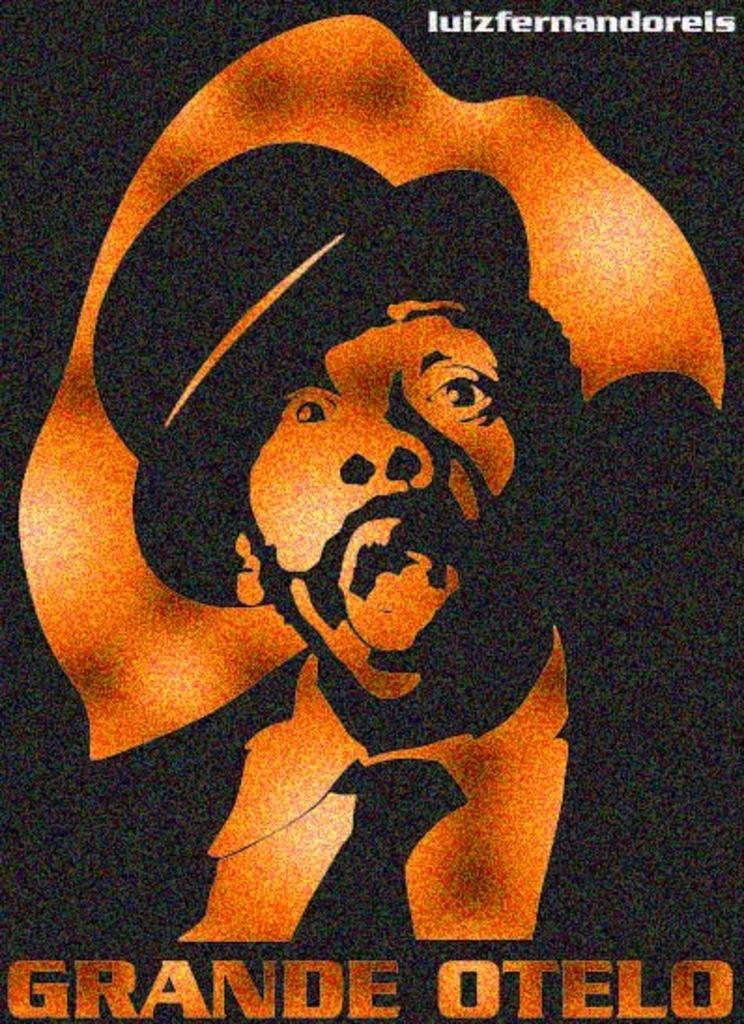What is featured in the image? There is a poster in the image. Can you describe the content of the poster? The poster contains a person. Are there any additional features on the poster? Yes, the poster has a watermark. What type of stem can be seen on the person's hand in the image? There is no stem or hand visible in the image; it features a poster with a person on it. 